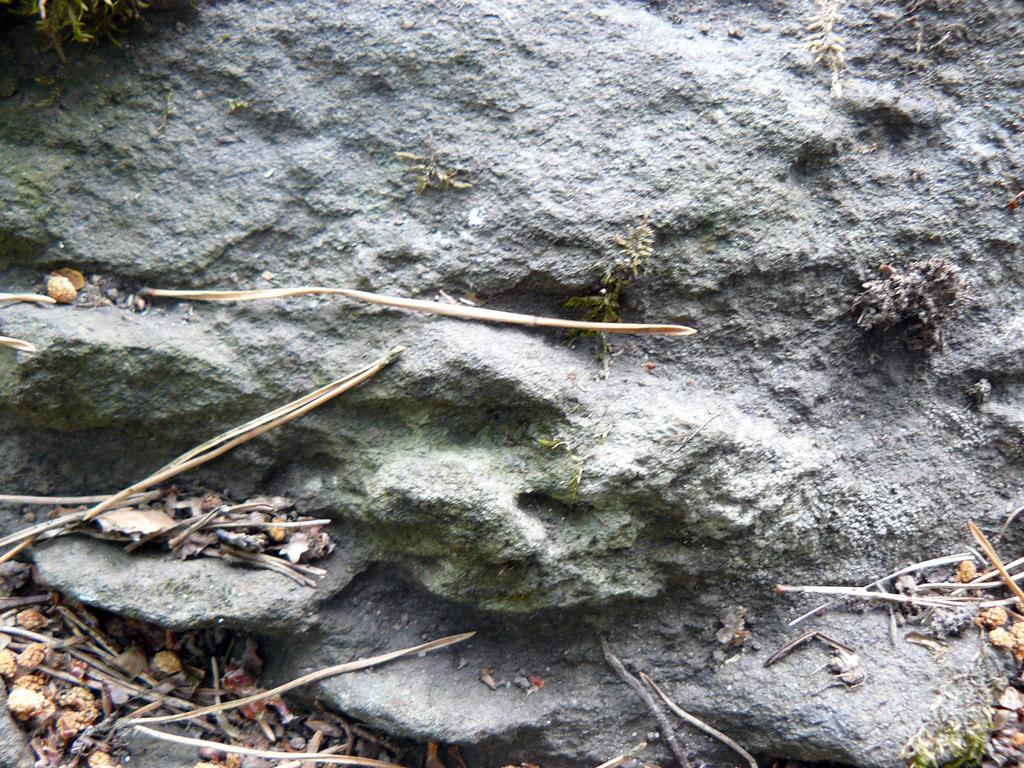What type of surface is visible in the image? There is a rock surface in the image. What natural elements can be seen on the rock surface? There are seeds and sticks visible on the rock surface. Can you tell me how many loaves of bread are touching the rock surface in the image? There is no bread present in the image; it only features a rock surface with seeds and sticks. 